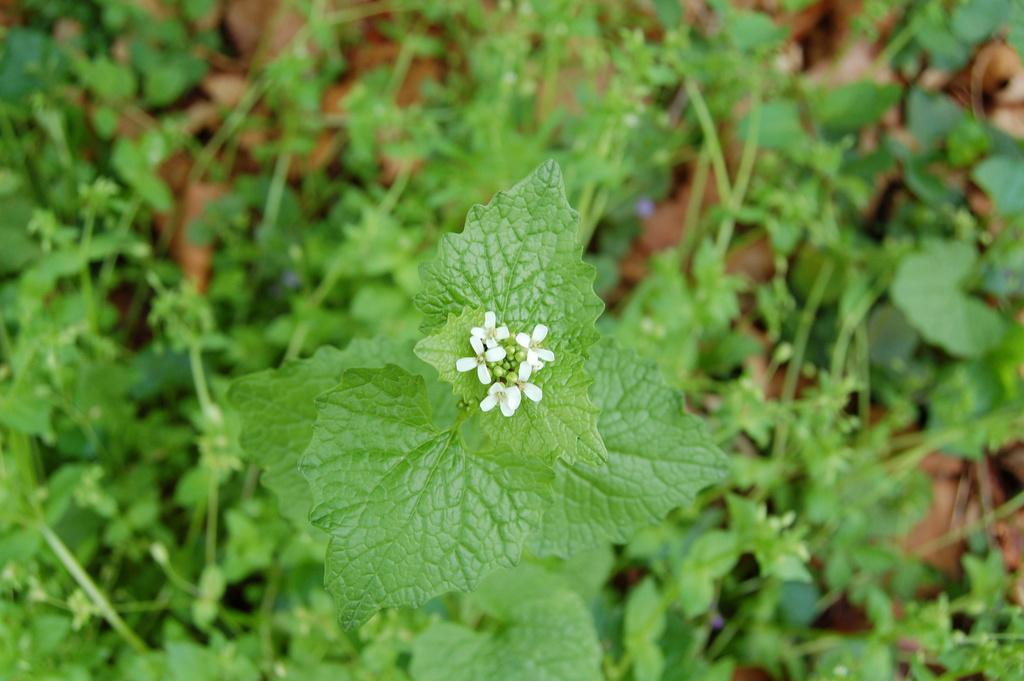Could you give a brief overview of what you see in this image? In the picture there are creeps present, there are flowers present. 